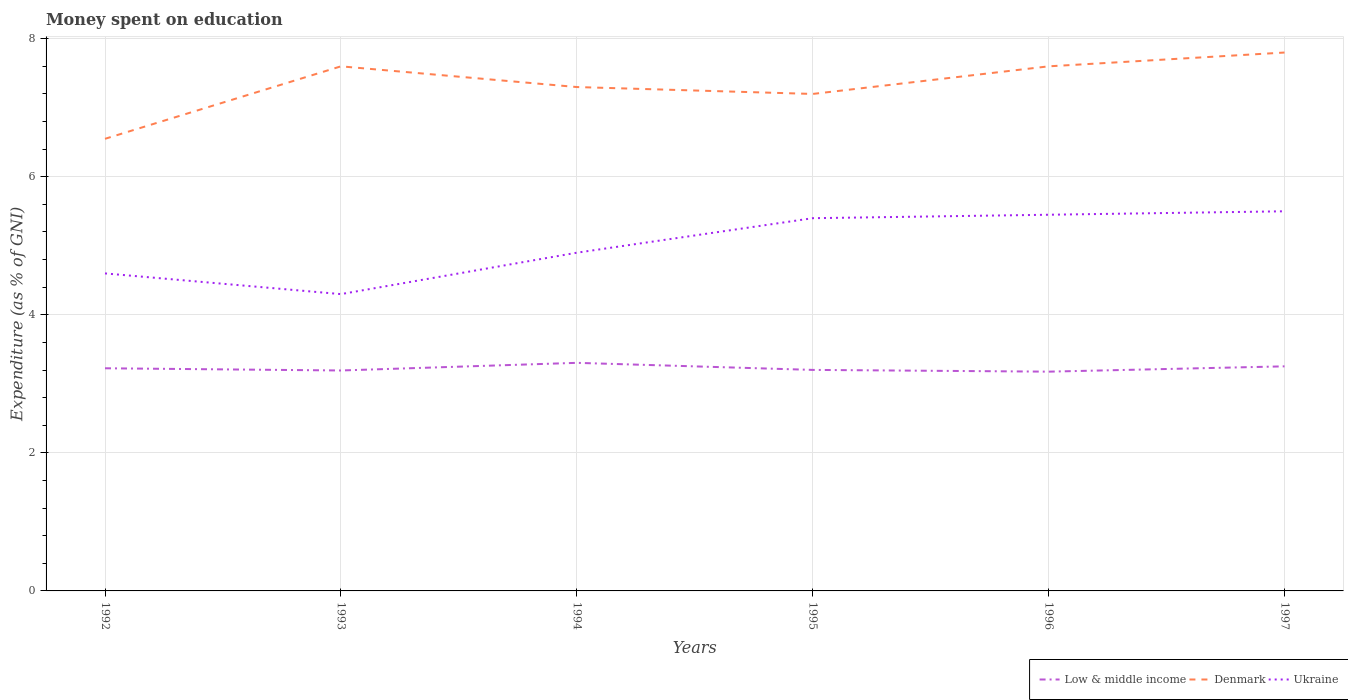Does the line corresponding to Low & middle income intersect with the line corresponding to Denmark?
Give a very brief answer. No. Is the number of lines equal to the number of legend labels?
Provide a succinct answer. Yes. Across all years, what is the maximum amount of money spent on education in Denmark?
Make the answer very short. 6.55. What is the total amount of money spent on education in Ukraine in the graph?
Your answer should be very brief. -0.05. What is the difference between the highest and the second highest amount of money spent on education in Denmark?
Your answer should be compact. 1.25. What is the difference between the highest and the lowest amount of money spent on education in Ukraine?
Provide a succinct answer. 3. Is the amount of money spent on education in Ukraine strictly greater than the amount of money spent on education in Denmark over the years?
Your answer should be compact. Yes. How many lines are there?
Offer a terse response. 3. How many years are there in the graph?
Your answer should be compact. 6. Does the graph contain any zero values?
Your response must be concise. No. How are the legend labels stacked?
Offer a terse response. Horizontal. What is the title of the graph?
Make the answer very short. Money spent on education. What is the label or title of the Y-axis?
Offer a terse response. Expenditure (as % of GNI). What is the Expenditure (as % of GNI) of Low & middle income in 1992?
Keep it short and to the point. 3.23. What is the Expenditure (as % of GNI) of Denmark in 1992?
Your answer should be compact. 6.55. What is the Expenditure (as % of GNI) of Ukraine in 1992?
Ensure brevity in your answer.  4.6. What is the Expenditure (as % of GNI) in Low & middle income in 1993?
Your response must be concise. 3.19. What is the Expenditure (as % of GNI) of Ukraine in 1993?
Your answer should be compact. 4.3. What is the Expenditure (as % of GNI) of Low & middle income in 1994?
Ensure brevity in your answer.  3.3. What is the Expenditure (as % of GNI) in Low & middle income in 1995?
Offer a terse response. 3.2. What is the Expenditure (as % of GNI) in Low & middle income in 1996?
Make the answer very short. 3.18. What is the Expenditure (as % of GNI) in Ukraine in 1996?
Keep it short and to the point. 5.45. What is the Expenditure (as % of GNI) of Low & middle income in 1997?
Offer a very short reply. 3.25. What is the Expenditure (as % of GNI) in Denmark in 1997?
Ensure brevity in your answer.  7.8. What is the Expenditure (as % of GNI) in Ukraine in 1997?
Your answer should be very brief. 5.5. Across all years, what is the maximum Expenditure (as % of GNI) in Low & middle income?
Give a very brief answer. 3.3. Across all years, what is the maximum Expenditure (as % of GNI) of Denmark?
Offer a terse response. 7.8. Across all years, what is the minimum Expenditure (as % of GNI) in Low & middle income?
Provide a succinct answer. 3.18. Across all years, what is the minimum Expenditure (as % of GNI) in Denmark?
Give a very brief answer. 6.55. Across all years, what is the minimum Expenditure (as % of GNI) in Ukraine?
Provide a succinct answer. 4.3. What is the total Expenditure (as % of GNI) of Low & middle income in the graph?
Your answer should be very brief. 19.36. What is the total Expenditure (as % of GNI) of Denmark in the graph?
Ensure brevity in your answer.  44.05. What is the total Expenditure (as % of GNI) of Ukraine in the graph?
Give a very brief answer. 30.15. What is the difference between the Expenditure (as % of GNI) of Low & middle income in 1992 and that in 1993?
Your answer should be compact. 0.03. What is the difference between the Expenditure (as % of GNI) in Denmark in 1992 and that in 1993?
Make the answer very short. -1.05. What is the difference between the Expenditure (as % of GNI) in Low & middle income in 1992 and that in 1994?
Provide a short and direct response. -0.08. What is the difference between the Expenditure (as % of GNI) in Denmark in 1992 and that in 1994?
Offer a terse response. -0.75. What is the difference between the Expenditure (as % of GNI) in Ukraine in 1992 and that in 1994?
Ensure brevity in your answer.  -0.3. What is the difference between the Expenditure (as % of GNI) in Low & middle income in 1992 and that in 1995?
Provide a succinct answer. 0.02. What is the difference between the Expenditure (as % of GNI) of Denmark in 1992 and that in 1995?
Provide a succinct answer. -0.65. What is the difference between the Expenditure (as % of GNI) of Low & middle income in 1992 and that in 1996?
Provide a succinct answer. 0.05. What is the difference between the Expenditure (as % of GNI) in Denmark in 1992 and that in 1996?
Offer a very short reply. -1.05. What is the difference between the Expenditure (as % of GNI) in Ukraine in 1992 and that in 1996?
Keep it short and to the point. -0.85. What is the difference between the Expenditure (as % of GNI) of Low & middle income in 1992 and that in 1997?
Provide a short and direct response. -0.03. What is the difference between the Expenditure (as % of GNI) in Denmark in 1992 and that in 1997?
Provide a short and direct response. -1.25. What is the difference between the Expenditure (as % of GNI) of Low & middle income in 1993 and that in 1994?
Ensure brevity in your answer.  -0.11. What is the difference between the Expenditure (as % of GNI) in Denmark in 1993 and that in 1994?
Your response must be concise. 0.3. What is the difference between the Expenditure (as % of GNI) in Low & middle income in 1993 and that in 1995?
Provide a succinct answer. -0.01. What is the difference between the Expenditure (as % of GNI) in Low & middle income in 1993 and that in 1996?
Keep it short and to the point. 0.02. What is the difference between the Expenditure (as % of GNI) in Ukraine in 1993 and that in 1996?
Provide a succinct answer. -1.15. What is the difference between the Expenditure (as % of GNI) in Low & middle income in 1993 and that in 1997?
Keep it short and to the point. -0.06. What is the difference between the Expenditure (as % of GNI) in Ukraine in 1993 and that in 1997?
Offer a very short reply. -1.2. What is the difference between the Expenditure (as % of GNI) in Low & middle income in 1994 and that in 1995?
Ensure brevity in your answer.  0.1. What is the difference between the Expenditure (as % of GNI) of Denmark in 1994 and that in 1995?
Offer a terse response. 0.1. What is the difference between the Expenditure (as % of GNI) of Ukraine in 1994 and that in 1995?
Your response must be concise. -0.5. What is the difference between the Expenditure (as % of GNI) in Low & middle income in 1994 and that in 1996?
Keep it short and to the point. 0.13. What is the difference between the Expenditure (as % of GNI) in Ukraine in 1994 and that in 1996?
Your response must be concise. -0.55. What is the difference between the Expenditure (as % of GNI) of Low & middle income in 1994 and that in 1997?
Offer a terse response. 0.05. What is the difference between the Expenditure (as % of GNI) of Ukraine in 1994 and that in 1997?
Make the answer very short. -0.6. What is the difference between the Expenditure (as % of GNI) of Low & middle income in 1995 and that in 1996?
Your response must be concise. 0.03. What is the difference between the Expenditure (as % of GNI) of Low & middle income in 1995 and that in 1997?
Keep it short and to the point. -0.05. What is the difference between the Expenditure (as % of GNI) of Low & middle income in 1996 and that in 1997?
Make the answer very short. -0.08. What is the difference between the Expenditure (as % of GNI) of Denmark in 1996 and that in 1997?
Your answer should be compact. -0.2. What is the difference between the Expenditure (as % of GNI) of Low & middle income in 1992 and the Expenditure (as % of GNI) of Denmark in 1993?
Your answer should be compact. -4.37. What is the difference between the Expenditure (as % of GNI) of Low & middle income in 1992 and the Expenditure (as % of GNI) of Ukraine in 1993?
Provide a short and direct response. -1.07. What is the difference between the Expenditure (as % of GNI) of Denmark in 1992 and the Expenditure (as % of GNI) of Ukraine in 1993?
Offer a very short reply. 2.25. What is the difference between the Expenditure (as % of GNI) in Low & middle income in 1992 and the Expenditure (as % of GNI) in Denmark in 1994?
Your answer should be very brief. -4.07. What is the difference between the Expenditure (as % of GNI) of Low & middle income in 1992 and the Expenditure (as % of GNI) of Ukraine in 1994?
Make the answer very short. -1.67. What is the difference between the Expenditure (as % of GNI) in Denmark in 1992 and the Expenditure (as % of GNI) in Ukraine in 1994?
Keep it short and to the point. 1.65. What is the difference between the Expenditure (as % of GNI) of Low & middle income in 1992 and the Expenditure (as % of GNI) of Denmark in 1995?
Provide a succinct answer. -3.97. What is the difference between the Expenditure (as % of GNI) in Low & middle income in 1992 and the Expenditure (as % of GNI) in Ukraine in 1995?
Offer a terse response. -2.17. What is the difference between the Expenditure (as % of GNI) in Denmark in 1992 and the Expenditure (as % of GNI) in Ukraine in 1995?
Your answer should be very brief. 1.15. What is the difference between the Expenditure (as % of GNI) of Low & middle income in 1992 and the Expenditure (as % of GNI) of Denmark in 1996?
Give a very brief answer. -4.37. What is the difference between the Expenditure (as % of GNI) of Low & middle income in 1992 and the Expenditure (as % of GNI) of Ukraine in 1996?
Offer a terse response. -2.22. What is the difference between the Expenditure (as % of GNI) of Low & middle income in 1992 and the Expenditure (as % of GNI) of Denmark in 1997?
Offer a very short reply. -4.57. What is the difference between the Expenditure (as % of GNI) in Low & middle income in 1992 and the Expenditure (as % of GNI) in Ukraine in 1997?
Provide a short and direct response. -2.27. What is the difference between the Expenditure (as % of GNI) of Low & middle income in 1993 and the Expenditure (as % of GNI) of Denmark in 1994?
Offer a terse response. -4.11. What is the difference between the Expenditure (as % of GNI) in Low & middle income in 1993 and the Expenditure (as % of GNI) in Ukraine in 1994?
Offer a terse response. -1.71. What is the difference between the Expenditure (as % of GNI) of Low & middle income in 1993 and the Expenditure (as % of GNI) of Denmark in 1995?
Make the answer very short. -4.01. What is the difference between the Expenditure (as % of GNI) of Low & middle income in 1993 and the Expenditure (as % of GNI) of Ukraine in 1995?
Provide a short and direct response. -2.21. What is the difference between the Expenditure (as % of GNI) in Low & middle income in 1993 and the Expenditure (as % of GNI) in Denmark in 1996?
Provide a succinct answer. -4.41. What is the difference between the Expenditure (as % of GNI) in Low & middle income in 1993 and the Expenditure (as % of GNI) in Ukraine in 1996?
Your answer should be very brief. -2.26. What is the difference between the Expenditure (as % of GNI) of Denmark in 1993 and the Expenditure (as % of GNI) of Ukraine in 1996?
Offer a terse response. 2.15. What is the difference between the Expenditure (as % of GNI) of Low & middle income in 1993 and the Expenditure (as % of GNI) of Denmark in 1997?
Give a very brief answer. -4.61. What is the difference between the Expenditure (as % of GNI) in Low & middle income in 1993 and the Expenditure (as % of GNI) in Ukraine in 1997?
Keep it short and to the point. -2.31. What is the difference between the Expenditure (as % of GNI) of Denmark in 1993 and the Expenditure (as % of GNI) of Ukraine in 1997?
Make the answer very short. 2.1. What is the difference between the Expenditure (as % of GNI) of Low & middle income in 1994 and the Expenditure (as % of GNI) of Denmark in 1995?
Provide a succinct answer. -3.9. What is the difference between the Expenditure (as % of GNI) of Low & middle income in 1994 and the Expenditure (as % of GNI) of Ukraine in 1995?
Your response must be concise. -2.1. What is the difference between the Expenditure (as % of GNI) of Denmark in 1994 and the Expenditure (as % of GNI) of Ukraine in 1995?
Offer a terse response. 1.9. What is the difference between the Expenditure (as % of GNI) in Low & middle income in 1994 and the Expenditure (as % of GNI) in Denmark in 1996?
Give a very brief answer. -4.3. What is the difference between the Expenditure (as % of GNI) in Low & middle income in 1994 and the Expenditure (as % of GNI) in Ukraine in 1996?
Ensure brevity in your answer.  -2.15. What is the difference between the Expenditure (as % of GNI) of Denmark in 1994 and the Expenditure (as % of GNI) of Ukraine in 1996?
Your response must be concise. 1.85. What is the difference between the Expenditure (as % of GNI) in Low & middle income in 1994 and the Expenditure (as % of GNI) in Denmark in 1997?
Make the answer very short. -4.5. What is the difference between the Expenditure (as % of GNI) in Low & middle income in 1994 and the Expenditure (as % of GNI) in Ukraine in 1997?
Provide a short and direct response. -2.2. What is the difference between the Expenditure (as % of GNI) of Low & middle income in 1995 and the Expenditure (as % of GNI) of Denmark in 1996?
Give a very brief answer. -4.4. What is the difference between the Expenditure (as % of GNI) in Low & middle income in 1995 and the Expenditure (as % of GNI) in Ukraine in 1996?
Keep it short and to the point. -2.25. What is the difference between the Expenditure (as % of GNI) in Denmark in 1995 and the Expenditure (as % of GNI) in Ukraine in 1996?
Your response must be concise. 1.75. What is the difference between the Expenditure (as % of GNI) of Low & middle income in 1995 and the Expenditure (as % of GNI) of Denmark in 1997?
Offer a very short reply. -4.6. What is the difference between the Expenditure (as % of GNI) in Low & middle income in 1995 and the Expenditure (as % of GNI) in Ukraine in 1997?
Ensure brevity in your answer.  -2.3. What is the difference between the Expenditure (as % of GNI) in Low & middle income in 1996 and the Expenditure (as % of GNI) in Denmark in 1997?
Offer a very short reply. -4.62. What is the difference between the Expenditure (as % of GNI) in Low & middle income in 1996 and the Expenditure (as % of GNI) in Ukraine in 1997?
Your response must be concise. -2.32. What is the average Expenditure (as % of GNI) in Low & middle income per year?
Your answer should be compact. 3.23. What is the average Expenditure (as % of GNI) in Denmark per year?
Give a very brief answer. 7.34. What is the average Expenditure (as % of GNI) of Ukraine per year?
Make the answer very short. 5.03. In the year 1992, what is the difference between the Expenditure (as % of GNI) of Low & middle income and Expenditure (as % of GNI) of Denmark?
Offer a very short reply. -3.32. In the year 1992, what is the difference between the Expenditure (as % of GNI) in Low & middle income and Expenditure (as % of GNI) in Ukraine?
Offer a very short reply. -1.37. In the year 1992, what is the difference between the Expenditure (as % of GNI) in Denmark and Expenditure (as % of GNI) in Ukraine?
Provide a short and direct response. 1.95. In the year 1993, what is the difference between the Expenditure (as % of GNI) of Low & middle income and Expenditure (as % of GNI) of Denmark?
Ensure brevity in your answer.  -4.41. In the year 1993, what is the difference between the Expenditure (as % of GNI) in Low & middle income and Expenditure (as % of GNI) in Ukraine?
Keep it short and to the point. -1.11. In the year 1993, what is the difference between the Expenditure (as % of GNI) in Denmark and Expenditure (as % of GNI) in Ukraine?
Provide a succinct answer. 3.3. In the year 1994, what is the difference between the Expenditure (as % of GNI) of Low & middle income and Expenditure (as % of GNI) of Denmark?
Your answer should be very brief. -4. In the year 1994, what is the difference between the Expenditure (as % of GNI) in Low & middle income and Expenditure (as % of GNI) in Ukraine?
Provide a short and direct response. -1.6. In the year 1994, what is the difference between the Expenditure (as % of GNI) of Denmark and Expenditure (as % of GNI) of Ukraine?
Your answer should be compact. 2.4. In the year 1995, what is the difference between the Expenditure (as % of GNI) of Low & middle income and Expenditure (as % of GNI) of Denmark?
Offer a very short reply. -4. In the year 1995, what is the difference between the Expenditure (as % of GNI) in Low & middle income and Expenditure (as % of GNI) in Ukraine?
Your answer should be compact. -2.2. In the year 1995, what is the difference between the Expenditure (as % of GNI) in Denmark and Expenditure (as % of GNI) in Ukraine?
Offer a terse response. 1.8. In the year 1996, what is the difference between the Expenditure (as % of GNI) of Low & middle income and Expenditure (as % of GNI) of Denmark?
Keep it short and to the point. -4.42. In the year 1996, what is the difference between the Expenditure (as % of GNI) of Low & middle income and Expenditure (as % of GNI) of Ukraine?
Offer a very short reply. -2.27. In the year 1996, what is the difference between the Expenditure (as % of GNI) of Denmark and Expenditure (as % of GNI) of Ukraine?
Offer a very short reply. 2.15. In the year 1997, what is the difference between the Expenditure (as % of GNI) of Low & middle income and Expenditure (as % of GNI) of Denmark?
Give a very brief answer. -4.55. In the year 1997, what is the difference between the Expenditure (as % of GNI) in Low & middle income and Expenditure (as % of GNI) in Ukraine?
Give a very brief answer. -2.25. In the year 1997, what is the difference between the Expenditure (as % of GNI) in Denmark and Expenditure (as % of GNI) in Ukraine?
Provide a short and direct response. 2.3. What is the ratio of the Expenditure (as % of GNI) in Denmark in 1992 to that in 1993?
Your response must be concise. 0.86. What is the ratio of the Expenditure (as % of GNI) of Ukraine in 1992 to that in 1993?
Ensure brevity in your answer.  1.07. What is the ratio of the Expenditure (as % of GNI) in Low & middle income in 1992 to that in 1994?
Keep it short and to the point. 0.98. What is the ratio of the Expenditure (as % of GNI) of Denmark in 1992 to that in 1994?
Your answer should be very brief. 0.9. What is the ratio of the Expenditure (as % of GNI) of Ukraine in 1992 to that in 1994?
Your answer should be very brief. 0.94. What is the ratio of the Expenditure (as % of GNI) of Low & middle income in 1992 to that in 1995?
Your response must be concise. 1.01. What is the ratio of the Expenditure (as % of GNI) of Denmark in 1992 to that in 1995?
Make the answer very short. 0.91. What is the ratio of the Expenditure (as % of GNI) in Ukraine in 1992 to that in 1995?
Your response must be concise. 0.85. What is the ratio of the Expenditure (as % of GNI) of Low & middle income in 1992 to that in 1996?
Your answer should be very brief. 1.02. What is the ratio of the Expenditure (as % of GNI) of Denmark in 1992 to that in 1996?
Provide a succinct answer. 0.86. What is the ratio of the Expenditure (as % of GNI) of Ukraine in 1992 to that in 1996?
Offer a terse response. 0.84. What is the ratio of the Expenditure (as % of GNI) of Low & middle income in 1992 to that in 1997?
Offer a very short reply. 0.99. What is the ratio of the Expenditure (as % of GNI) in Denmark in 1992 to that in 1997?
Offer a very short reply. 0.84. What is the ratio of the Expenditure (as % of GNI) of Ukraine in 1992 to that in 1997?
Your response must be concise. 0.84. What is the ratio of the Expenditure (as % of GNI) in Low & middle income in 1993 to that in 1994?
Ensure brevity in your answer.  0.97. What is the ratio of the Expenditure (as % of GNI) of Denmark in 1993 to that in 1994?
Offer a terse response. 1.04. What is the ratio of the Expenditure (as % of GNI) in Ukraine in 1993 to that in 1994?
Offer a very short reply. 0.88. What is the ratio of the Expenditure (as % of GNI) in Low & middle income in 1993 to that in 1995?
Offer a terse response. 1. What is the ratio of the Expenditure (as % of GNI) of Denmark in 1993 to that in 1995?
Your answer should be very brief. 1.06. What is the ratio of the Expenditure (as % of GNI) in Ukraine in 1993 to that in 1995?
Offer a very short reply. 0.8. What is the ratio of the Expenditure (as % of GNI) of Ukraine in 1993 to that in 1996?
Keep it short and to the point. 0.79. What is the ratio of the Expenditure (as % of GNI) in Low & middle income in 1993 to that in 1997?
Give a very brief answer. 0.98. What is the ratio of the Expenditure (as % of GNI) of Denmark in 1993 to that in 1997?
Keep it short and to the point. 0.97. What is the ratio of the Expenditure (as % of GNI) in Ukraine in 1993 to that in 1997?
Provide a short and direct response. 0.78. What is the ratio of the Expenditure (as % of GNI) of Low & middle income in 1994 to that in 1995?
Give a very brief answer. 1.03. What is the ratio of the Expenditure (as % of GNI) in Denmark in 1994 to that in 1995?
Keep it short and to the point. 1.01. What is the ratio of the Expenditure (as % of GNI) of Ukraine in 1994 to that in 1995?
Keep it short and to the point. 0.91. What is the ratio of the Expenditure (as % of GNI) in Low & middle income in 1994 to that in 1996?
Your response must be concise. 1.04. What is the ratio of the Expenditure (as % of GNI) of Denmark in 1994 to that in 1996?
Ensure brevity in your answer.  0.96. What is the ratio of the Expenditure (as % of GNI) of Ukraine in 1994 to that in 1996?
Offer a terse response. 0.9. What is the ratio of the Expenditure (as % of GNI) of Low & middle income in 1994 to that in 1997?
Provide a succinct answer. 1.02. What is the ratio of the Expenditure (as % of GNI) in Denmark in 1994 to that in 1997?
Give a very brief answer. 0.94. What is the ratio of the Expenditure (as % of GNI) of Ukraine in 1994 to that in 1997?
Provide a short and direct response. 0.89. What is the ratio of the Expenditure (as % of GNI) in Low & middle income in 1995 to that in 1997?
Ensure brevity in your answer.  0.98. What is the ratio of the Expenditure (as % of GNI) of Ukraine in 1995 to that in 1997?
Keep it short and to the point. 0.98. What is the ratio of the Expenditure (as % of GNI) in Low & middle income in 1996 to that in 1997?
Your answer should be compact. 0.98. What is the ratio of the Expenditure (as % of GNI) in Denmark in 1996 to that in 1997?
Give a very brief answer. 0.97. What is the ratio of the Expenditure (as % of GNI) of Ukraine in 1996 to that in 1997?
Keep it short and to the point. 0.99. What is the difference between the highest and the second highest Expenditure (as % of GNI) in Low & middle income?
Make the answer very short. 0.05. What is the difference between the highest and the second highest Expenditure (as % of GNI) in Denmark?
Keep it short and to the point. 0.2. What is the difference between the highest and the second highest Expenditure (as % of GNI) of Ukraine?
Provide a succinct answer. 0.05. What is the difference between the highest and the lowest Expenditure (as % of GNI) of Low & middle income?
Keep it short and to the point. 0.13. What is the difference between the highest and the lowest Expenditure (as % of GNI) in Ukraine?
Ensure brevity in your answer.  1.2. 